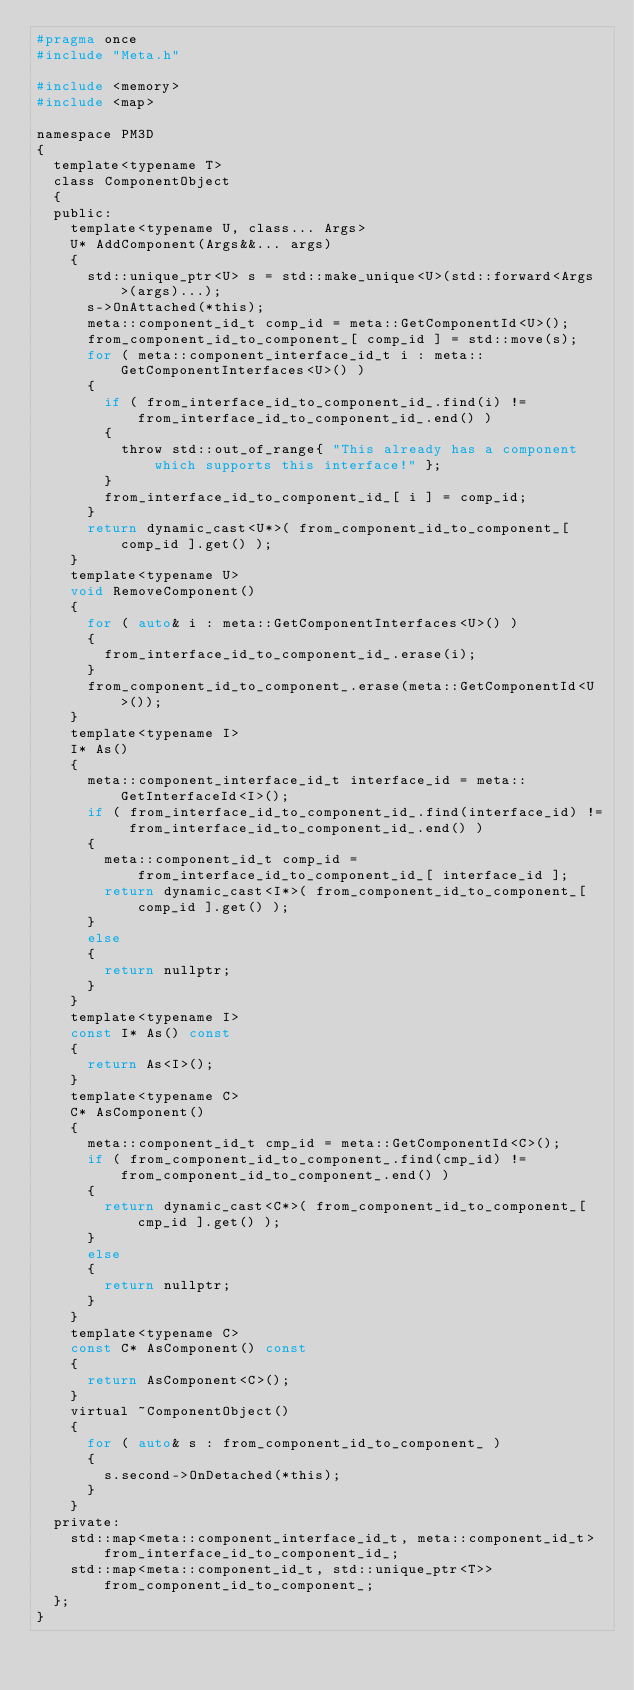<code> <loc_0><loc_0><loc_500><loc_500><_C_>#pragma once
#include "Meta.h"

#include <memory>
#include <map>

namespace PM3D
{
  template<typename T>
  class ComponentObject
  {
  public:
    template<typename U, class... Args>
    U* AddComponent(Args&&... args)
    {
      std::unique_ptr<U> s = std::make_unique<U>(std::forward<Args>(args)...);
      s->OnAttached(*this);
      meta::component_id_t comp_id = meta::GetComponentId<U>();
      from_component_id_to_component_[ comp_id ] = std::move(s);
      for ( meta::component_interface_id_t i : meta::GetComponentInterfaces<U>() )
      {
        if ( from_interface_id_to_component_id_.find(i) != from_interface_id_to_component_id_.end() )
        {
          throw std::out_of_range{ "This already has a component which supports this interface!" };
        }
        from_interface_id_to_component_id_[ i ] = comp_id;
      }
      return dynamic_cast<U*>( from_component_id_to_component_[ comp_id ].get() );
    }
    template<typename U>
    void RemoveComponent()
    {
      for ( auto& i : meta::GetComponentInterfaces<U>() )
      {
        from_interface_id_to_component_id_.erase(i);
      }
      from_component_id_to_component_.erase(meta::GetComponentId<U>());
    }
    template<typename I>
    I* As()
    {
      meta::component_interface_id_t interface_id = meta::GetInterfaceId<I>();
      if ( from_interface_id_to_component_id_.find(interface_id) != from_interface_id_to_component_id_.end() )
      {
        meta::component_id_t comp_id = from_interface_id_to_component_id_[ interface_id ];
        return dynamic_cast<I*>( from_component_id_to_component_[ comp_id ].get() );
      }
      else
      {
        return nullptr;
      }
    }
    template<typename I>
    const I* As() const
    {
      return As<I>();
    }
    template<typename C>
    C* AsComponent()
    {
      meta::component_id_t cmp_id = meta::GetComponentId<C>();
      if ( from_component_id_to_component_.find(cmp_id) != from_component_id_to_component_.end() )
      {
        return dynamic_cast<C*>( from_component_id_to_component_[ cmp_id ].get() );
      }
      else
      {
        return nullptr;
      }
    }
    template<typename C>
    const C* AsComponent() const
    {
      return AsComponent<C>();
    }
    virtual ~ComponentObject()
    {
      for ( auto& s : from_component_id_to_component_ )
      {
        s.second->OnDetached(*this);
      }
    }
  private:
    std::map<meta::component_interface_id_t, meta::component_id_t> from_interface_id_to_component_id_;
    std::map<meta::component_id_t, std::unique_ptr<T>> from_component_id_to_component_;
  };
}</code> 